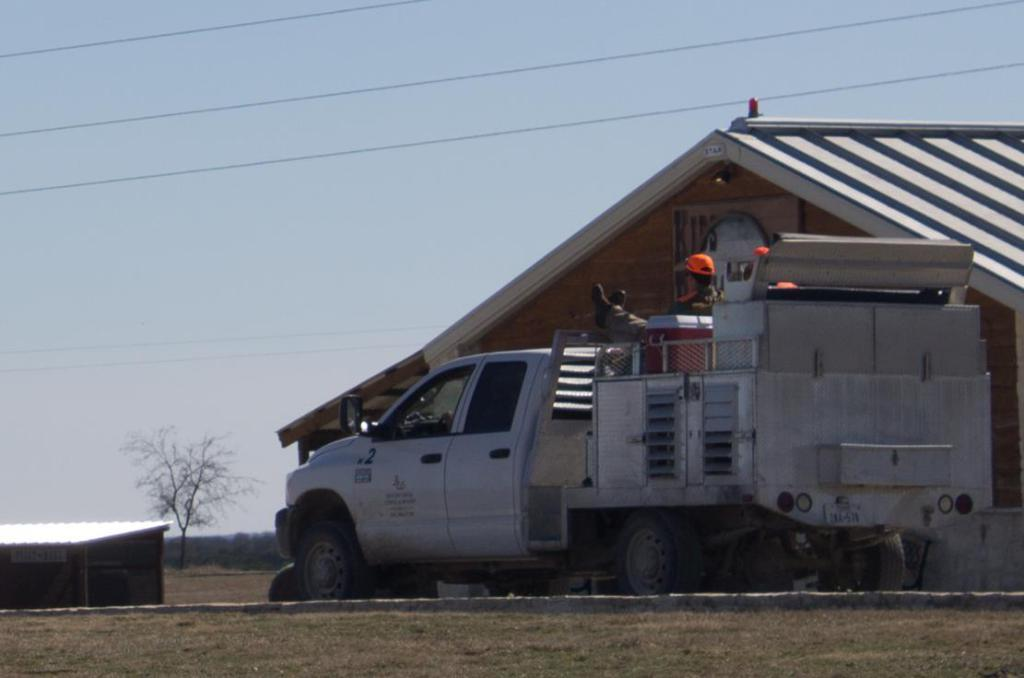What are the people in the image doing? The people in the image are riding a vehicle. What can be seen at the bottom of the image? The ground is visible at the bottom of the image. What structures can be seen in the background of the image? There is a house and a shed in the background of the image. What type of vegetation is visible in the background of the image? Trees are present in the background of the image. What else is visible in the background of the image? The sky and wires are visible in the background of the image. What type of nose can be seen on the maid in the image? There is no maid present in the image, and therefore no nose to describe. What type of road can be seen in the image? There is no road visible in the image; it features people riding a vehicle in a setting with a house, shed, trees, sky, and wires. 